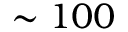Convert formula to latex. <formula><loc_0><loc_0><loc_500><loc_500>\sim 1 0 0</formula> 